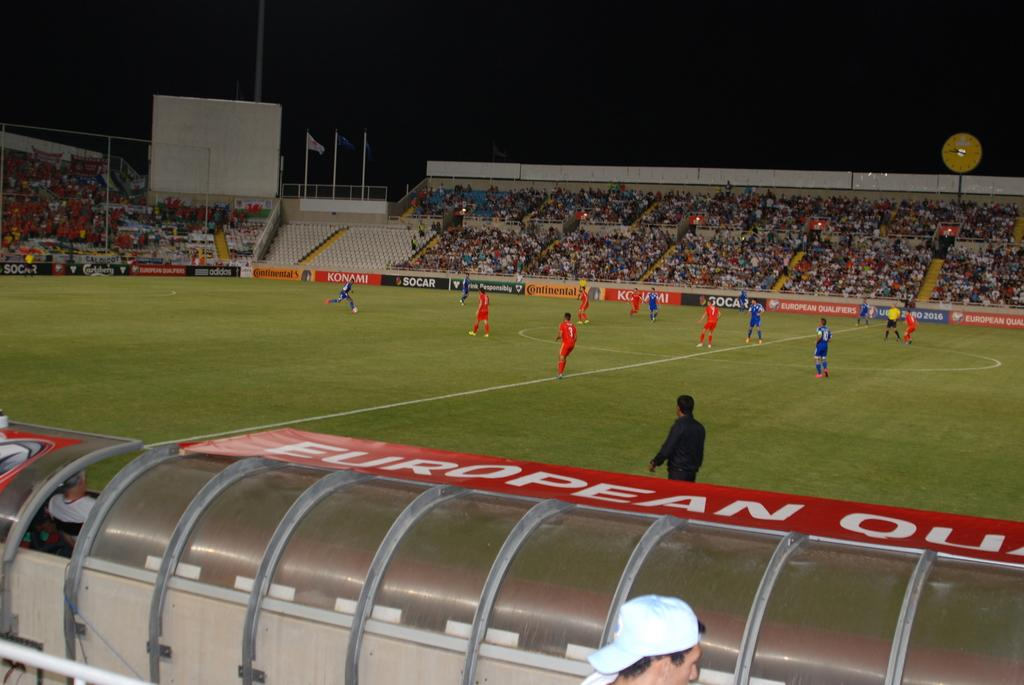Provide a one-sentence caption for the provided image. The walls of a soccer stadium contain ads for Konami and Adidias, plus many more. 